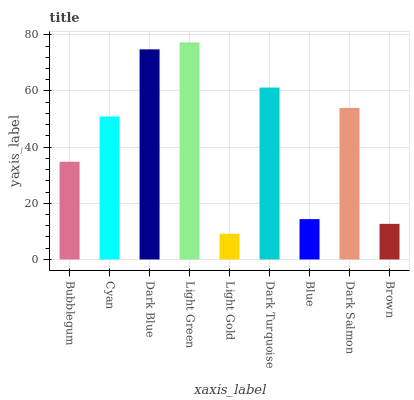Is Cyan the minimum?
Answer yes or no. No. Is Cyan the maximum?
Answer yes or no. No. Is Cyan greater than Bubblegum?
Answer yes or no. Yes. Is Bubblegum less than Cyan?
Answer yes or no. Yes. Is Bubblegum greater than Cyan?
Answer yes or no. No. Is Cyan less than Bubblegum?
Answer yes or no. No. Is Cyan the high median?
Answer yes or no. Yes. Is Cyan the low median?
Answer yes or no. Yes. Is Light Green the high median?
Answer yes or no. No. Is Dark Blue the low median?
Answer yes or no. No. 